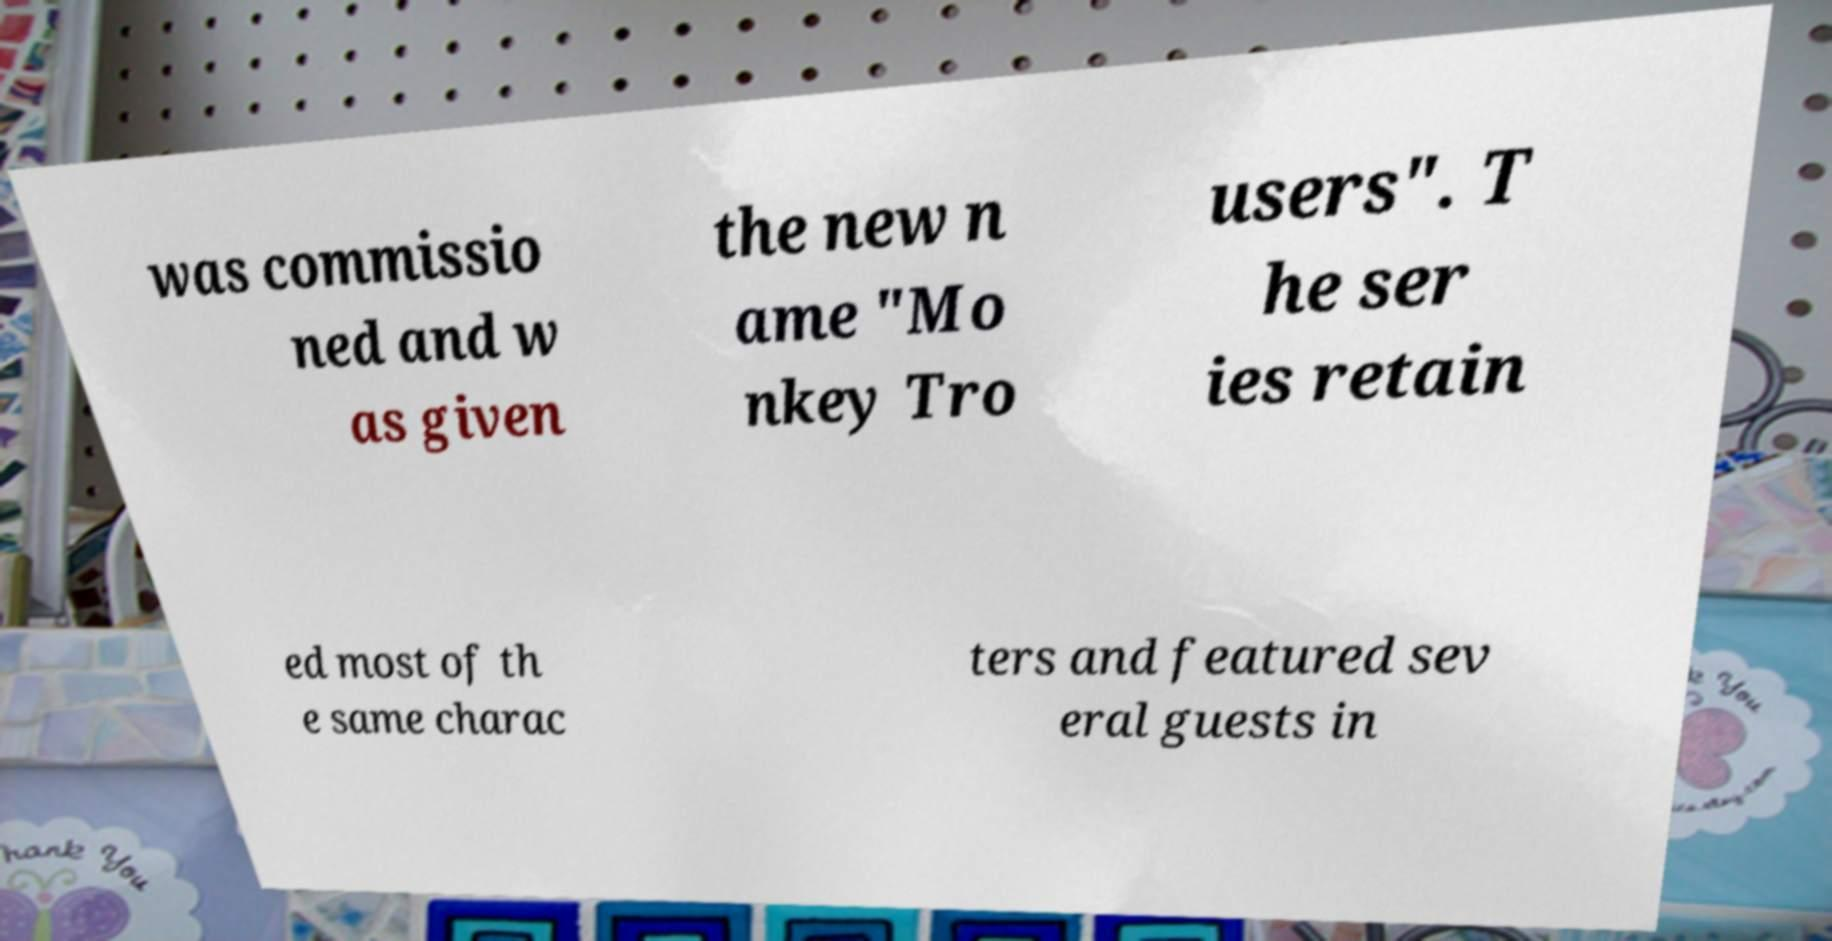I need the written content from this picture converted into text. Can you do that? was commissio ned and w as given the new n ame "Mo nkey Tro users". T he ser ies retain ed most of th e same charac ters and featured sev eral guests in 